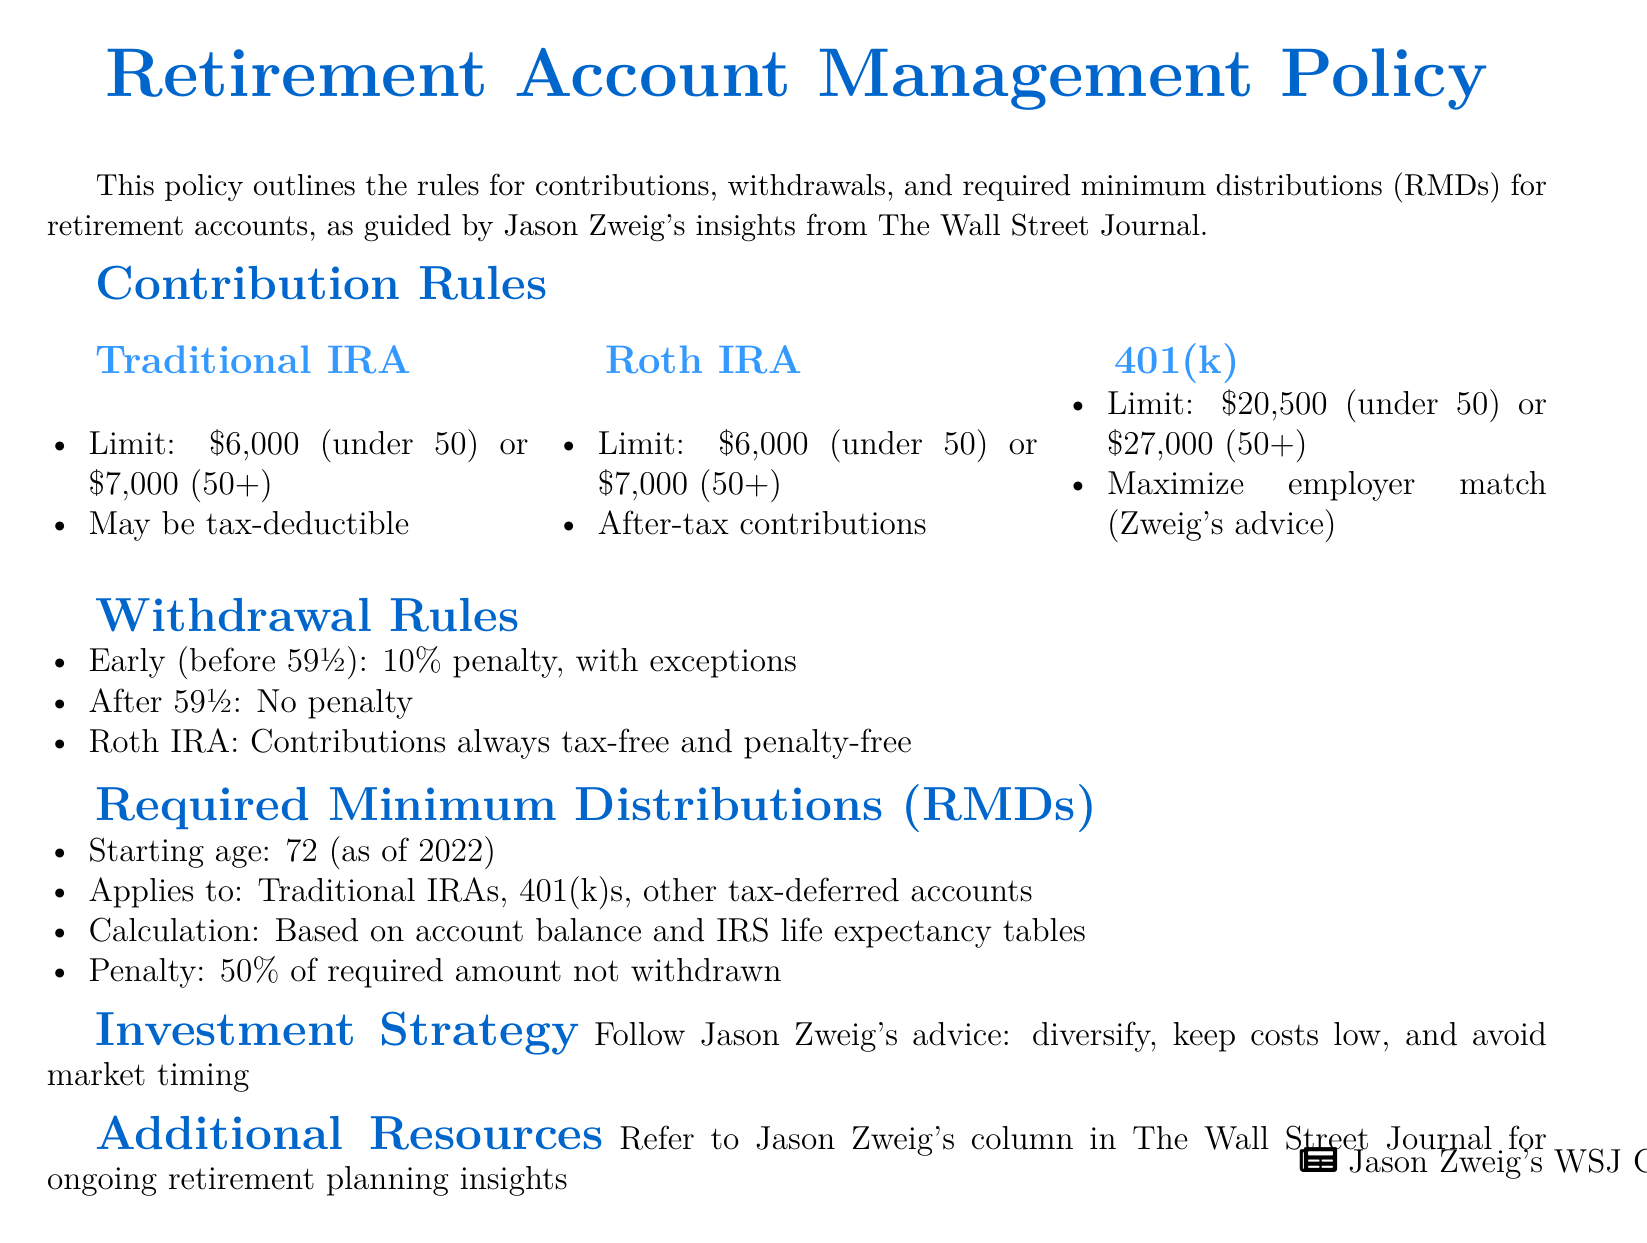What is the contribution limit for a Traditional IRA for individuals under age 50? The contribution limit for a Traditional IRA for individuals under age 50 is stated in the policy.
Answer: $6,000 What is the contribution limit for a 401(k) for individuals aged 50 and over? The policy outlines the contribution limits for a 401(k), specifically for individuals aged 50 and over.
Answer: $27,000 At what age do Required Minimum Distributions (RMDs) begin? The policy specifies the starting age for Required Minimum Distributions (RMDs).
Answer: 72 What penalty applies to early withdrawals (before age 59½)? The document mentions a specific penalty for early withdrawals which is indicated in the withdrawal rules.
Answer: 10% Which type of retirement account allows contributions to be tax-free and penalty-free at any time? The policy provides information about the Roth IRA and its unique feature regarding contributions.
Answer: Roth IRA What advice does Jason Zweig give regarding employer match for 401(k) contributions? The document refers to Zweig's recommendation related to maximizing contributions when an employer match is available.
Answer: Maximize employer match What is the penalty for not withdrawing the required minimum amount from retirement accounts? The policy indicates a specific penalty for failing to adhere to the required minimum distributions.
Answer: 50% What strategy does the policy recommend for investment management? The document addresses investment strategies and specifically mentions guidance from Jason Zweig.
Answer: Diversify, keep costs low, avoid market timing What types of accounts are subject to Required Minimum Distributions? The policy lists specific types of accounts that are required to have minimum distributions, which informs the reader about relevant accounts.
Answer: Traditional IRAs, 401(k)s, other tax-deferred accounts 